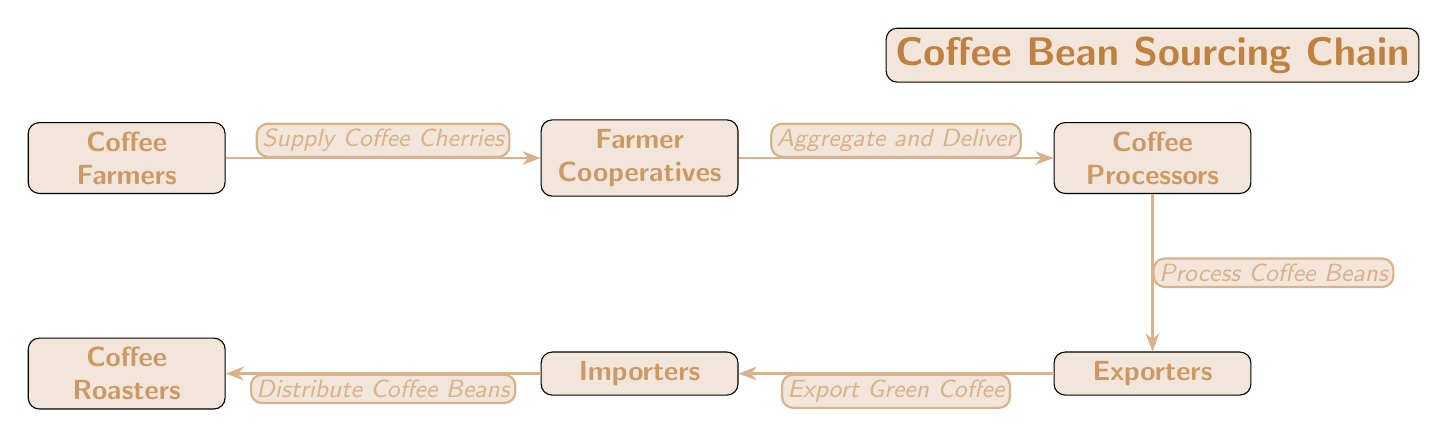What are the first two entities in the coffee sourcing chain? The diagram shows the flow starting from the Coffee Farmers and then moving to the Farmer Cooperatives, indicating these are the first two entities in the chain.
Answer: Coffee Farmers, Farmer Cooperatives How many nodes are there in the coffee sourcing chain? By counting the entities represented in the diagram, we determine that there are a total of six nodes: Coffee Farmers, Farmer Cooperatives, Coffee Processors, Exporters, Importers, and Coffee Roasters.
Answer: 6 What is the role of Farmer Cooperatives in the diagram? The Farmer Cooperatives are depicted as responsible for aggregating and delivering coffee cherries from the farmers to the next stage of processing, following their connection arrow.
Answer: Aggregate and Deliver Who are the last entities that receive coffee beans? According to the flow of the diagram, Coffee Roasters are the final recipients of the coffee beans after they are distributed by the Importers.
Answer: Coffee Roasters Which entity is directly connected to Exporters? The diagram illustrates that Coffee Processors are directly connected to Exporters, indicating that Coffee Processors supply them with processed coffee beans.
Answer: Coffee Processors What is the flow direction of the coffee sourcing chain? Observing the arrows in the diagram indicates that the flow of the coffee sourcing chain moves from left to right, starting from farmers and ending at roasters.
Answer: Left to right 